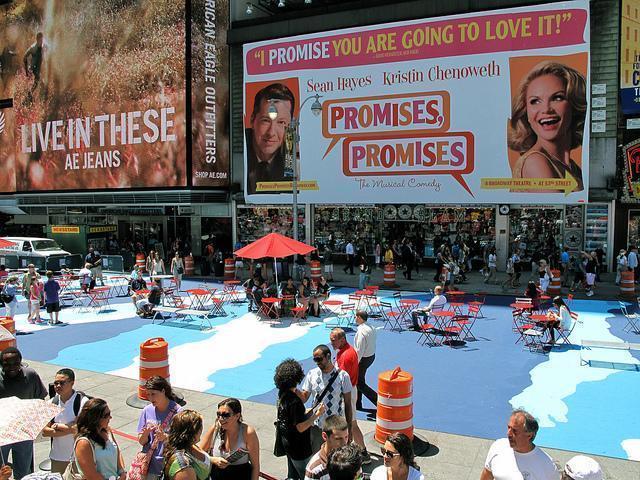What type traffic is allowed to go through this street at this time?
From the following four choices, select the correct answer to address the question.
Options: Foot only, all, buses, motorcycles. Foot only. 